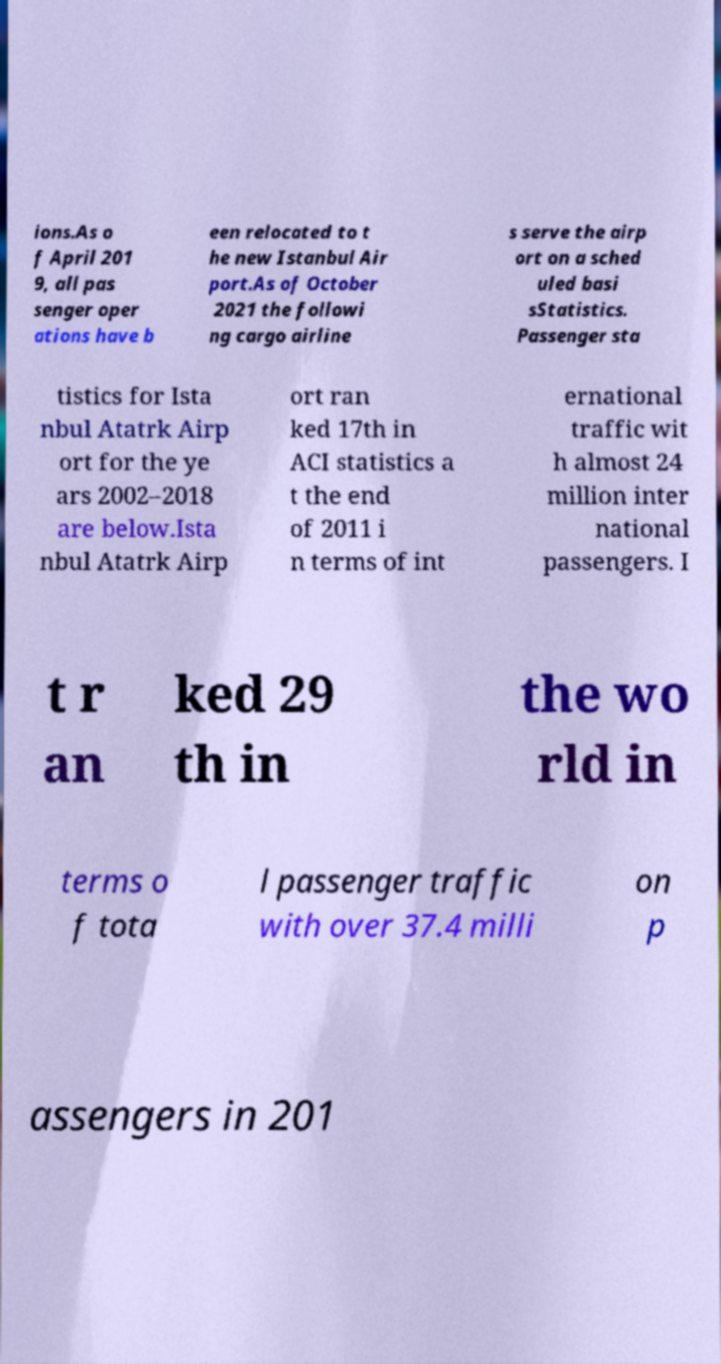Could you extract and type out the text from this image? ions.As o f April 201 9, all pas senger oper ations have b een relocated to t he new Istanbul Air port.As of October 2021 the followi ng cargo airline s serve the airp ort on a sched uled basi sStatistics. Passenger sta tistics for Ista nbul Atatrk Airp ort for the ye ars 2002–2018 are below.Ista nbul Atatrk Airp ort ran ked 17th in ACI statistics a t the end of 2011 i n terms of int ernational traffic wit h almost 24 million inter national passengers. I t r an ked 29 th in the wo rld in terms o f tota l passenger traffic with over 37.4 milli on p assengers in 201 